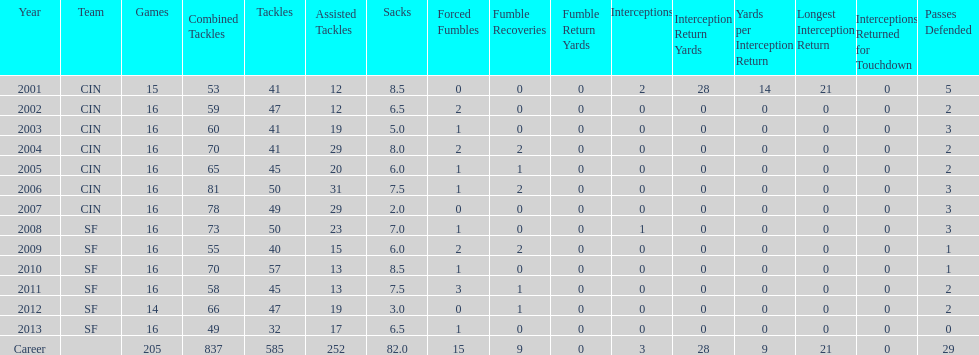In his first five seasons, how many sacks did this player accomplish? 34. 